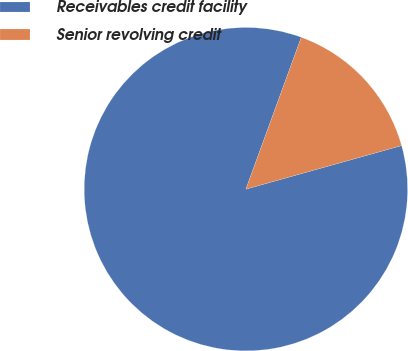Convert chart. <chart><loc_0><loc_0><loc_500><loc_500><pie_chart><fcel>Receivables credit facility<fcel>Senior revolving credit<nl><fcel>84.91%<fcel>15.09%<nl></chart> 